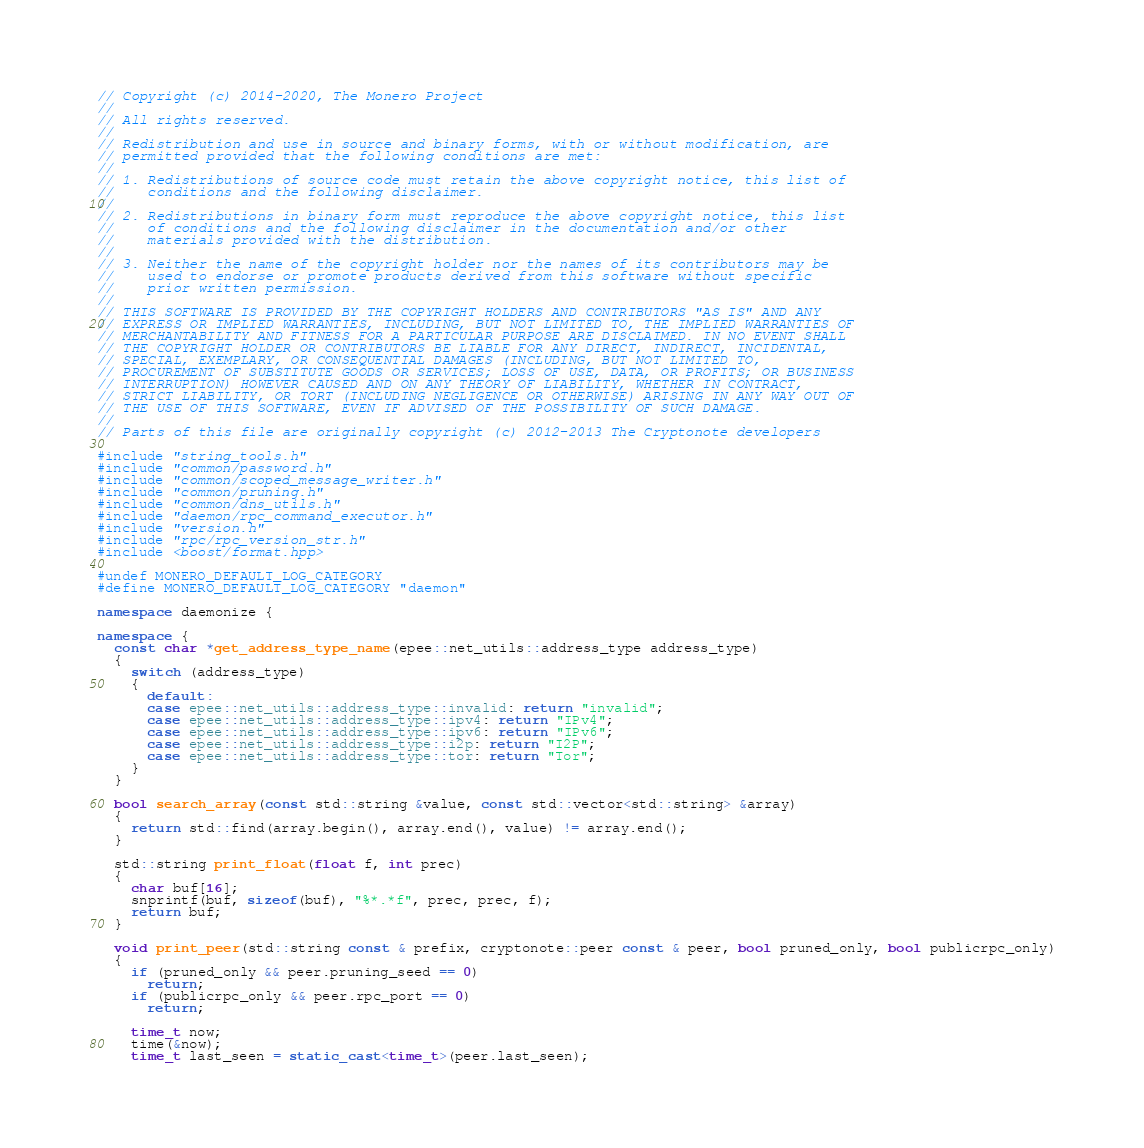Convert code to text. <code><loc_0><loc_0><loc_500><loc_500><_C++_>// Copyright (c) 2014-2020, The Monero Project
//
// All rights reserved.
//
// Redistribution and use in source and binary forms, with or without modification, are
// permitted provided that the following conditions are met:
//
// 1. Redistributions of source code must retain the above copyright notice, this list of
//    conditions and the following disclaimer.
//
// 2. Redistributions in binary form must reproduce the above copyright notice, this list
//    of conditions and the following disclaimer in the documentation and/or other
//    materials provided with the distribution.
//
// 3. Neither the name of the copyright holder nor the names of its contributors may be
//    used to endorse or promote products derived from this software without specific
//    prior written permission.
//
// THIS SOFTWARE IS PROVIDED BY THE COPYRIGHT HOLDERS AND CONTRIBUTORS "AS IS" AND ANY
// EXPRESS OR IMPLIED WARRANTIES, INCLUDING, BUT NOT LIMITED TO, THE IMPLIED WARRANTIES OF
// MERCHANTABILITY AND FITNESS FOR A PARTICULAR PURPOSE ARE DISCLAIMED. IN NO EVENT SHALL
// THE COPYRIGHT HOLDER OR CONTRIBUTORS BE LIABLE FOR ANY DIRECT, INDIRECT, INCIDENTAL,
// SPECIAL, EXEMPLARY, OR CONSEQUENTIAL DAMAGES (INCLUDING, BUT NOT LIMITED TO,
// PROCUREMENT OF SUBSTITUTE GOODS OR SERVICES; LOSS OF USE, DATA, OR PROFITS; OR BUSINESS
// INTERRUPTION) HOWEVER CAUSED AND ON ANY THEORY OF LIABILITY, WHETHER IN CONTRACT,
// STRICT LIABILITY, OR TORT (INCLUDING NEGLIGENCE OR OTHERWISE) ARISING IN ANY WAY OUT OF
// THE USE OF THIS SOFTWARE, EVEN IF ADVISED OF THE POSSIBILITY OF SUCH DAMAGE.
//
// Parts of this file are originally copyright (c) 2012-2013 The Cryptonote developers

#include "string_tools.h"
#include "common/password.h"
#include "common/scoped_message_writer.h"
#include "common/pruning.h"
#include "common/dns_utils.h"
#include "daemon/rpc_command_executor.h"
#include "version.h"
#include "rpc/rpc_version_str.h"
#include <boost/format.hpp>

#undef MONERO_DEFAULT_LOG_CATEGORY
#define MONERO_DEFAULT_LOG_CATEGORY "daemon"

namespace daemonize {

namespace {
  const char *get_address_type_name(epee::net_utils::address_type address_type)
  {
    switch (address_type)
    {
      default:
      case epee::net_utils::address_type::invalid: return "invalid";
      case epee::net_utils::address_type::ipv4: return "IPv4";
      case epee::net_utils::address_type::ipv6: return "IPv6";
      case epee::net_utils::address_type::i2p: return "I2P";
      case epee::net_utils::address_type::tor: return "Tor";
    }
  }

  bool search_array(const std::string &value, const std::vector<std::string> &array)
  {
    return std::find(array.begin(), array.end(), value) != array.end();
  }

  std::string print_float(float f, int prec)
  {
    char buf[16];
    snprintf(buf, sizeof(buf), "%*.*f", prec, prec, f);
    return buf;
  }

  void print_peer(std::string const & prefix, cryptonote::peer const & peer, bool pruned_only, bool publicrpc_only)
  {
    if (pruned_only && peer.pruning_seed == 0)
      return;
    if (publicrpc_only && peer.rpc_port == 0)
      return;

    time_t now;
    time(&now);
    time_t last_seen = static_cast<time_t>(peer.last_seen);
</code> 